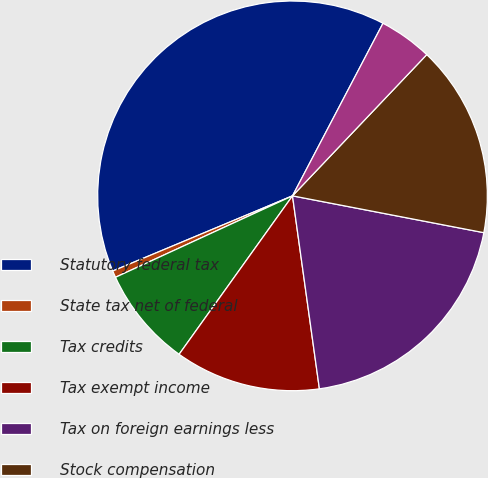Convert chart to OTSL. <chart><loc_0><loc_0><loc_500><loc_500><pie_chart><fcel>Statutory federal tax<fcel>State tax net of federal<fcel>Tax credits<fcel>Tax exempt income<fcel>Tax on foreign earnings less<fcel>Stock compensation<fcel>Other<nl><fcel>38.99%<fcel>0.56%<fcel>8.25%<fcel>12.09%<fcel>19.77%<fcel>15.93%<fcel>4.41%<nl></chart> 